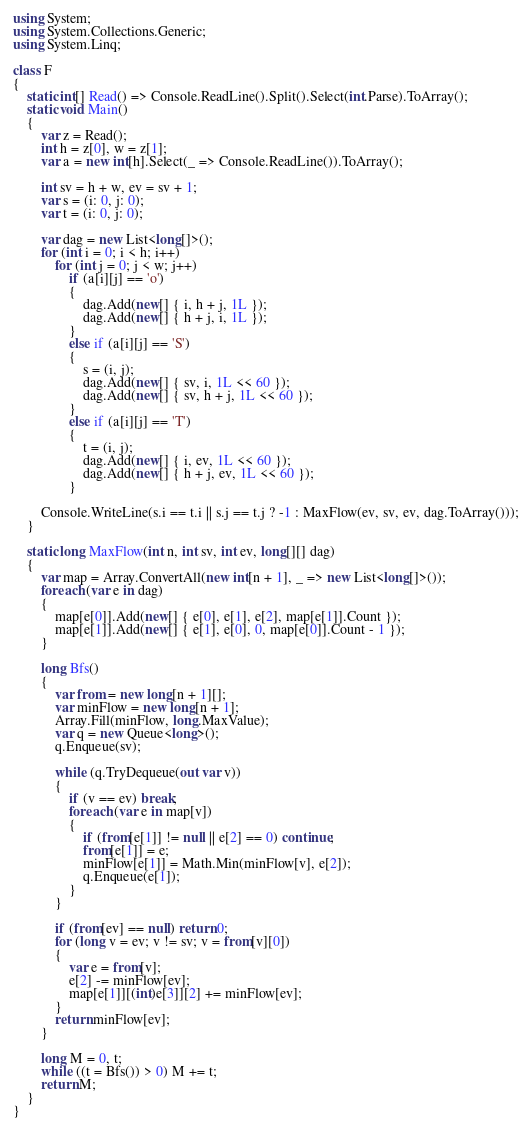<code> <loc_0><loc_0><loc_500><loc_500><_C#_>using System;
using System.Collections.Generic;
using System.Linq;

class F
{
	static int[] Read() => Console.ReadLine().Split().Select(int.Parse).ToArray();
	static void Main()
	{
		var z = Read();
		int h = z[0], w = z[1];
		var a = new int[h].Select(_ => Console.ReadLine()).ToArray();

		int sv = h + w, ev = sv + 1;
		var s = (i: 0, j: 0);
		var t = (i: 0, j: 0);

		var dag = new List<long[]>();
		for (int i = 0; i < h; i++)
			for (int j = 0; j < w; j++)
				if (a[i][j] == 'o')
				{
					dag.Add(new[] { i, h + j, 1L });
					dag.Add(new[] { h + j, i, 1L });
				}
				else if (a[i][j] == 'S')
				{
					s = (i, j);
					dag.Add(new[] { sv, i, 1L << 60 });
					dag.Add(new[] { sv, h + j, 1L << 60 });
				}
				else if (a[i][j] == 'T')
				{
					t = (i, j);
					dag.Add(new[] { i, ev, 1L << 60 });
					dag.Add(new[] { h + j, ev, 1L << 60 });
				}

		Console.WriteLine(s.i == t.i || s.j == t.j ? -1 : MaxFlow(ev, sv, ev, dag.ToArray()));
	}

	static long MaxFlow(int n, int sv, int ev, long[][] dag)
	{
		var map = Array.ConvertAll(new int[n + 1], _ => new List<long[]>());
		foreach (var e in dag)
		{
			map[e[0]].Add(new[] { e[0], e[1], e[2], map[e[1]].Count });
			map[e[1]].Add(new[] { e[1], e[0], 0, map[e[0]].Count - 1 });
		}

		long Bfs()
		{
			var from = new long[n + 1][];
			var minFlow = new long[n + 1];
			Array.Fill(minFlow, long.MaxValue);
			var q = new Queue<long>();
			q.Enqueue(sv);

			while (q.TryDequeue(out var v))
			{
				if (v == ev) break;
				foreach (var e in map[v])
				{
					if (from[e[1]] != null || e[2] == 0) continue;
					from[e[1]] = e;
					minFlow[e[1]] = Math.Min(minFlow[v], e[2]);
					q.Enqueue(e[1]);
				}
			}

			if (from[ev] == null) return 0;
			for (long v = ev; v != sv; v = from[v][0])
			{
				var e = from[v];
				e[2] -= minFlow[ev];
				map[e[1]][(int)e[3]][2] += minFlow[ev];
			}
			return minFlow[ev];
		}

		long M = 0, t;
		while ((t = Bfs()) > 0) M += t;
		return M;
	}
}
</code> 